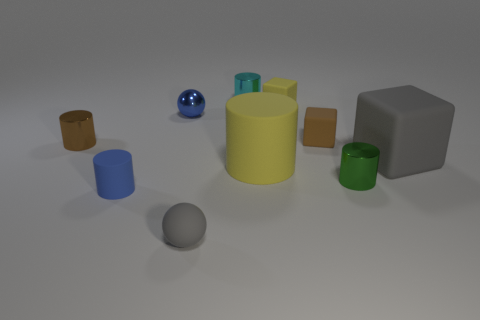Subtract all green cylinders. How many cylinders are left? 4 Subtract all small matte blocks. How many blocks are left? 1 Subtract 1 cylinders. How many cylinders are left? 4 Subtract all cyan cylinders. Subtract all cyan balls. How many cylinders are left? 4 Subtract all spheres. How many objects are left? 8 Subtract 1 green cylinders. How many objects are left? 9 Subtract all big yellow metallic spheres. Subtract all brown metal cylinders. How many objects are left? 9 Add 3 tiny metallic spheres. How many tiny metallic spheres are left? 4 Add 7 big red matte objects. How many big red matte objects exist? 7 